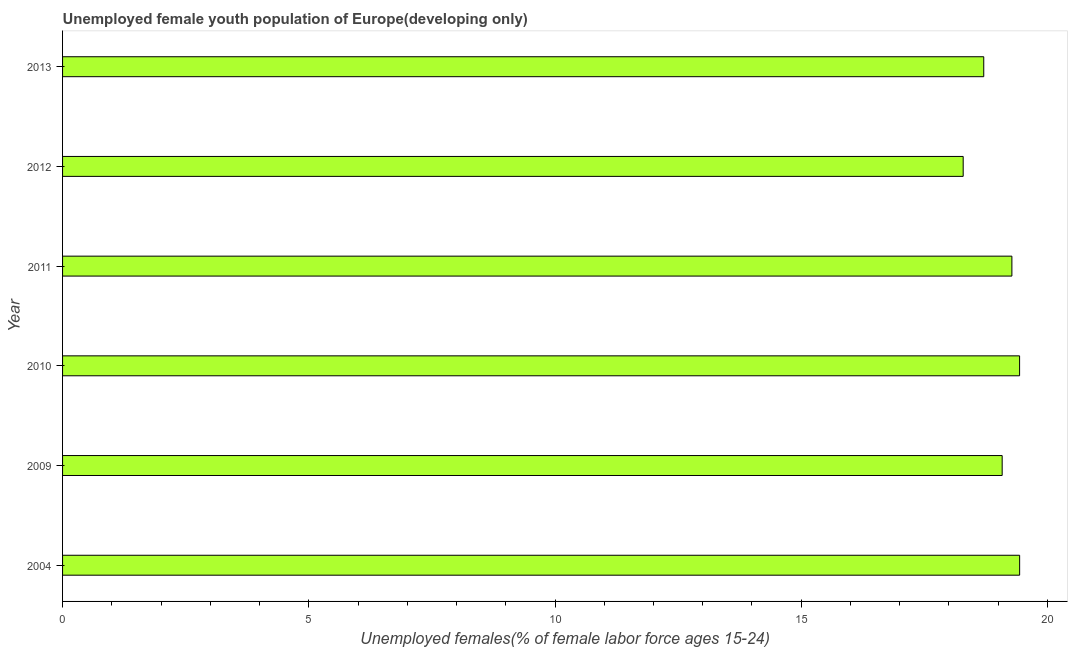Does the graph contain any zero values?
Offer a very short reply. No. What is the title of the graph?
Make the answer very short. Unemployed female youth population of Europe(developing only). What is the label or title of the X-axis?
Make the answer very short. Unemployed females(% of female labor force ages 15-24). What is the label or title of the Y-axis?
Give a very brief answer. Year. What is the unemployed female youth in 2004?
Offer a terse response. 19.44. Across all years, what is the maximum unemployed female youth?
Ensure brevity in your answer.  19.44. Across all years, what is the minimum unemployed female youth?
Make the answer very short. 18.29. In which year was the unemployed female youth minimum?
Offer a terse response. 2012. What is the sum of the unemployed female youth?
Offer a terse response. 114.23. What is the difference between the unemployed female youth in 2004 and 2009?
Your response must be concise. 0.35. What is the average unemployed female youth per year?
Your answer should be compact. 19.04. What is the median unemployed female youth?
Provide a short and direct response. 19.18. Do a majority of the years between 2013 and 2012 (inclusive) have unemployed female youth greater than 16 %?
Make the answer very short. No. Is the unemployed female youth in 2009 less than that in 2012?
Ensure brevity in your answer.  No. Is the difference between the unemployed female youth in 2009 and 2012 greater than the difference between any two years?
Offer a very short reply. No. What is the difference between the highest and the second highest unemployed female youth?
Make the answer very short. 0. What is the difference between the highest and the lowest unemployed female youth?
Keep it short and to the point. 1.15. Are all the bars in the graph horizontal?
Offer a very short reply. Yes. Are the values on the major ticks of X-axis written in scientific E-notation?
Provide a short and direct response. No. What is the Unemployed females(% of female labor force ages 15-24) in 2004?
Ensure brevity in your answer.  19.44. What is the Unemployed females(% of female labor force ages 15-24) in 2009?
Provide a short and direct response. 19.08. What is the Unemployed females(% of female labor force ages 15-24) of 2010?
Your answer should be very brief. 19.43. What is the Unemployed females(% of female labor force ages 15-24) in 2011?
Provide a short and direct response. 19.28. What is the Unemployed females(% of female labor force ages 15-24) in 2012?
Keep it short and to the point. 18.29. What is the Unemployed females(% of female labor force ages 15-24) of 2013?
Your answer should be compact. 18.71. What is the difference between the Unemployed females(% of female labor force ages 15-24) in 2004 and 2009?
Give a very brief answer. 0.35. What is the difference between the Unemployed females(% of female labor force ages 15-24) in 2004 and 2010?
Provide a succinct answer. 0. What is the difference between the Unemployed females(% of female labor force ages 15-24) in 2004 and 2011?
Your response must be concise. 0.16. What is the difference between the Unemployed females(% of female labor force ages 15-24) in 2004 and 2012?
Make the answer very short. 1.15. What is the difference between the Unemployed females(% of female labor force ages 15-24) in 2004 and 2013?
Provide a short and direct response. 0.73. What is the difference between the Unemployed females(% of female labor force ages 15-24) in 2009 and 2010?
Offer a terse response. -0.35. What is the difference between the Unemployed females(% of female labor force ages 15-24) in 2009 and 2011?
Give a very brief answer. -0.2. What is the difference between the Unemployed females(% of female labor force ages 15-24) in 2009 and 2012?
Offer a very short reply. 0.79. What is the difference between the Unemployed females(% of female labor force ages 15-24) in 2009 and 2013?
Keep it short and to the point. 0.37. What is the difference between the Unemployed females(% of female labor force ages 15-24) in 2010 and 2011?
Give a very brief answer. 0.16. What is the difference between the Unemployed females(% of female labor force ages 15-24) in 2010 and 2012?
Provide a short and direct response. 1.15. What is the difference between the Unemployed females(% of female labor force ages 15-24) in 2010 and 2013?
Give a very brief answer. 0.73. What is the difference between the Unemployed females(% of female labor force ages 15-24) in 2011 and 2012?
Make the answer very short. 0.99. What is the difference between the Unemployed females(% of female labor force ages 15-24) in 2011 and 2013?
Offer a terse response. 0.57. What is the difference between the Unemployed females(% of female labor force ages 15-24) in 2012 and 2013?
Give a very brief answer. -0.42. What is the ratio of the Unemployed females(% of female labor force ages 15-24) in 2004 to that in 2009?
Keep it short and to the point. 1.02. What is the ratio of the Unemployed females(% of female labor force ages 15-24) in 2004 to that in 2012?
Your response must be concise. 1.06. What is the ratio of the Unemployed females(% of female labor force ages 15-24) in 2004 to that in 2013?
Give a very brief answer. 1.04. What is the ratio of the Unemployed females(% of female labor force ages 15-24) in 2009 to that in 2011?
Your response must be concise. 0.99. What is the ratio of the Unemployed females(% of female labor force ages 15-24) in 2009 to that in 2012?
Your answer should be compact. 1.04. What is the ratio of the Unemployed females(% of female labor force ages 15-24) in 2009 to that in 2013?
Keep it short and to the point. 1.02. What is the ratio of the Unemployed females(% of female labor force ages 15-24) in 2010 to that in 2012?
Your answer should be very brief. 1.06. What is the ratio of the Unemployed females(% of female labor force ages 15-24) in 2010 to that in 2013?
Your answer should be compact. 1.04. What is the ratio of the Unemployed females(% of female labor force ages 15-24) in 2011 to that in 2012?
Make the answer very short. 1.05. What is the ratio of the Unemployed females(% of female labor force ages 15-24) in 2011 to that in 2013?
Provide a succinct answer. 1.03. 